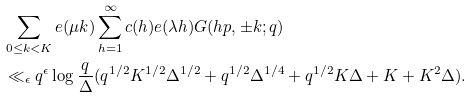Convert formula to latex. <formula><loc_0><loc_0><loc_500><loc_500>& \sum _ { 0 \leq k < K } e ( \mu k ) \sum _ { h = 1 } ^ { \infty } c ( h ) e ( \lambda h ) G ( h p , \pm k ; q ) \\ & \ll _ { \epsilon } q ^ { \epsilon } \log { \frac { q } { \Delta } } ( q ^ { 1 / 2 } K ^ { 1 / 2 } \Delta ^ { 1 / 2 } + q ^ { 1 / 2 } \Delta ^ { 1 / 4 } + q ^ { 1 / 2 } K \Delta + K + K ^ { 2 } \Delta ) .</formula> 